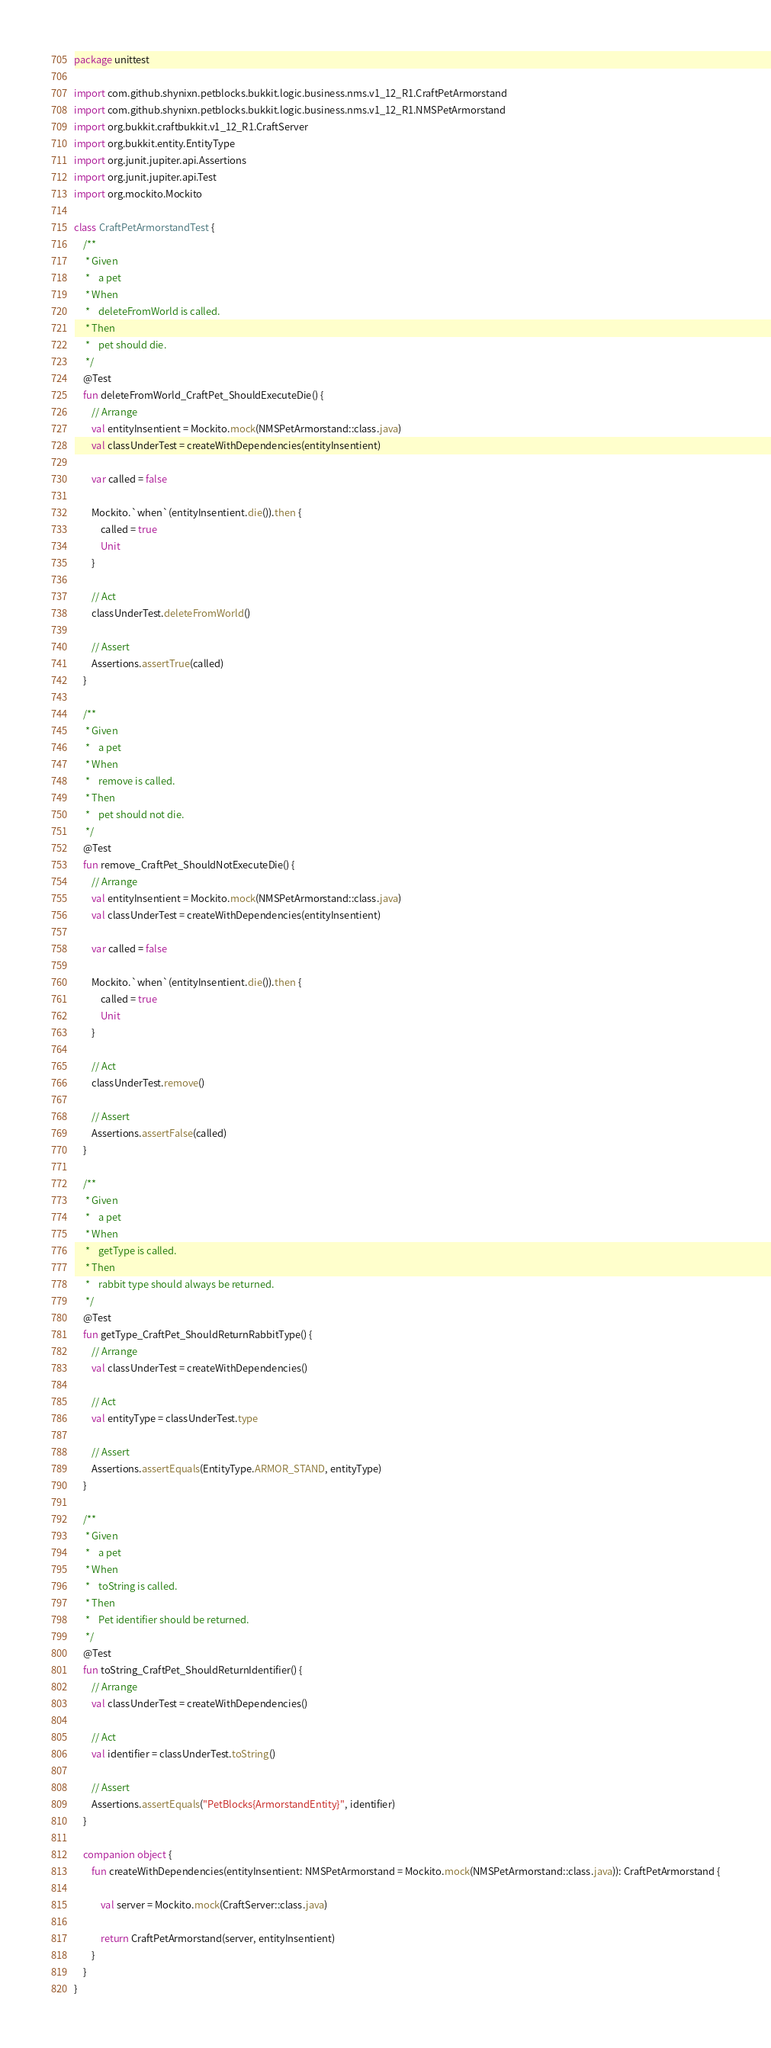Convert code to text. <code><loc_0><loc_0><loc_500><loc_500><_Kotlin_>package unittest

import com.github.shynixn.petblocks.bukkit.logic.business.nms.v1_12_R1.CraftPetArmorstand
import com.github.shynixn.petblocks.bukkit.logic.business.nms.v1_12_R1.NMSPetArmorstand
import org.bukkit.craftbukkit.v1_12_R1.CraftServer
import org.bukkit.entity.EntityType
import org.junit.jupiter.api.Assertions
import org.junit.jupiter.api.Test
import org.mockito.Mockito

class CraftPetArmorstandTest {
    /**
     * Given
     *    a pet
     * When
     *    deleteFromWorld is called.
     * Then
     *    pet should die.
     */
    @Test
    fun deleteFromWorld_CraftPet_ShouldExecuteDie() {
        // Arrange
        val entityInsentient = Mockito.mock(NMSPetArmorstand::class.java)
        val classUnderTest = createWithDependencies(entityInsentient)

        var called = false

        Mockito.`when`(entityInsentient.die()).then {
            called = true
            Unit
        }

        // Act
        classUnderTest.deleteFromWorld()

        // Assert
        Assertions.assertTrue(called)
    }

    /**
     * Given
     *    a pet
     * When
     *    remove is called.
     * Then
     *    pet should not die.
     */
    @Test
    fun remove_CraftPet_ShouldNotExecuteDie() {
        // Arrange
        val entityInsentient = Mockito.mock(NMSPetArmorstand::class.java)
        val classUnderTest = createWithDependencies(entityInsentient)

        var called = false

        Mockito.`when`(entityInsentient.die()).then {
            called = true
            Unit
        }

        // Act
        classUnderTest.remove()

        // Assert
        Assertions.assertFalse(called)
    }

    /**
     * Given
     *    a pet
     * When
     *    getType is called.
     * Then
     *    rabbit type should always be returned.
     */
    @Test
    fun getType_CraftPet_ShouldReturnRabbitType() {
        // Arrange
        val classUnderTest = createWithDependencies()

        // Act
        val entityType = classUnderTest.type

        // Assert
        Assertions.assertEquals(EntityType.ARMOR_STAND, entityType)
    }

    /**
     * Given
     *    a pet
     * When
     *    toString is called.
     * Then
     *    Pet identifier should be returned.
     */
    @Test
    fun toString_CraftPet_ShouldReturnIdentifier() {
        // Arrange
        val classUnderTest = createWithDependencies()

        // Act
        val identifier = classUnderTest.toString()

        // Assert
        Assertions.assertEquals("PetBlocks{ArmorstandEntity}", identifier)
    }

    companion object {
        fun createWithDependencies(entityInsentient: NMSPetArmorstand = Mockito.mock(NMSPetArmorstand::class.java)): CraftPetArmorstand {

            val server = Mockito.mock(CraftServer::class.java)

            return CraftPetArmorstand(server, entityInsentient)
        }
    }
}</code> 